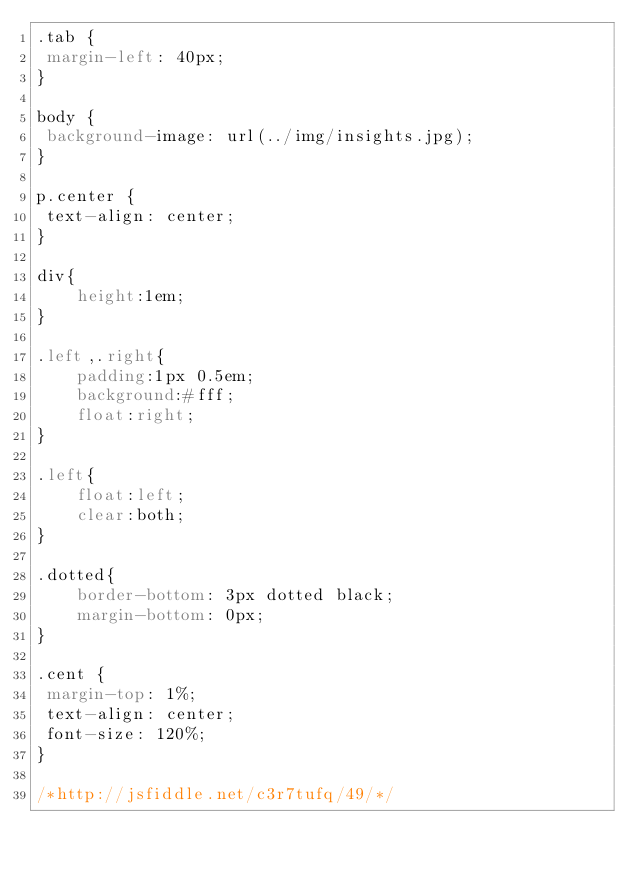Convert code to text. <code><loc_0><loc_0><loc_500><loc_500><_CSS_>.tab {
 margin-left: 40px;
}

body {
 background-image: url(../img/insights.jpg);
}

p.center {
 text-align: center;
}

div{
    height:1em;
}

.left,.right{
    padding:1px 0.5em;
    background:#fff;
    float:right;
}

.left{
    float:left;
    clear:both;
}

.dotted{
    border-bottom: 3px dotted black;
    margin-bottom: 0px;
}

.cent {
 margin-top: 1%;
 text-align: center;
 font-size: 120%;
}

/*http://jsfiddle.net/c3r7tufq/49/*/</code> 